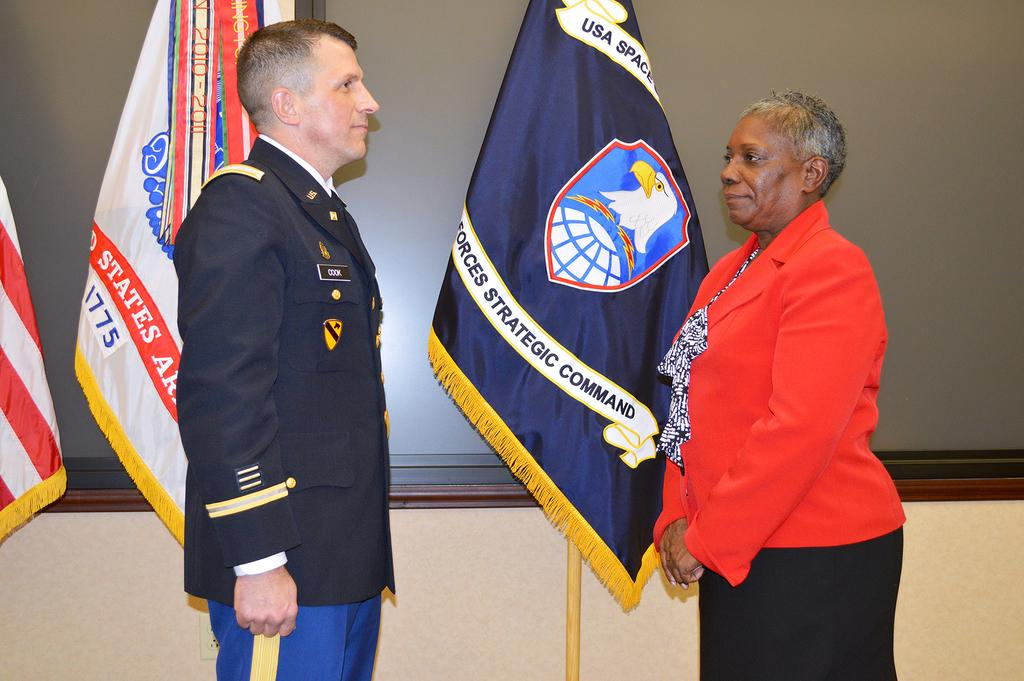<image>
Write a terse but informative summary of the picture. A man stands in front of flags with Cook on his name tag. 